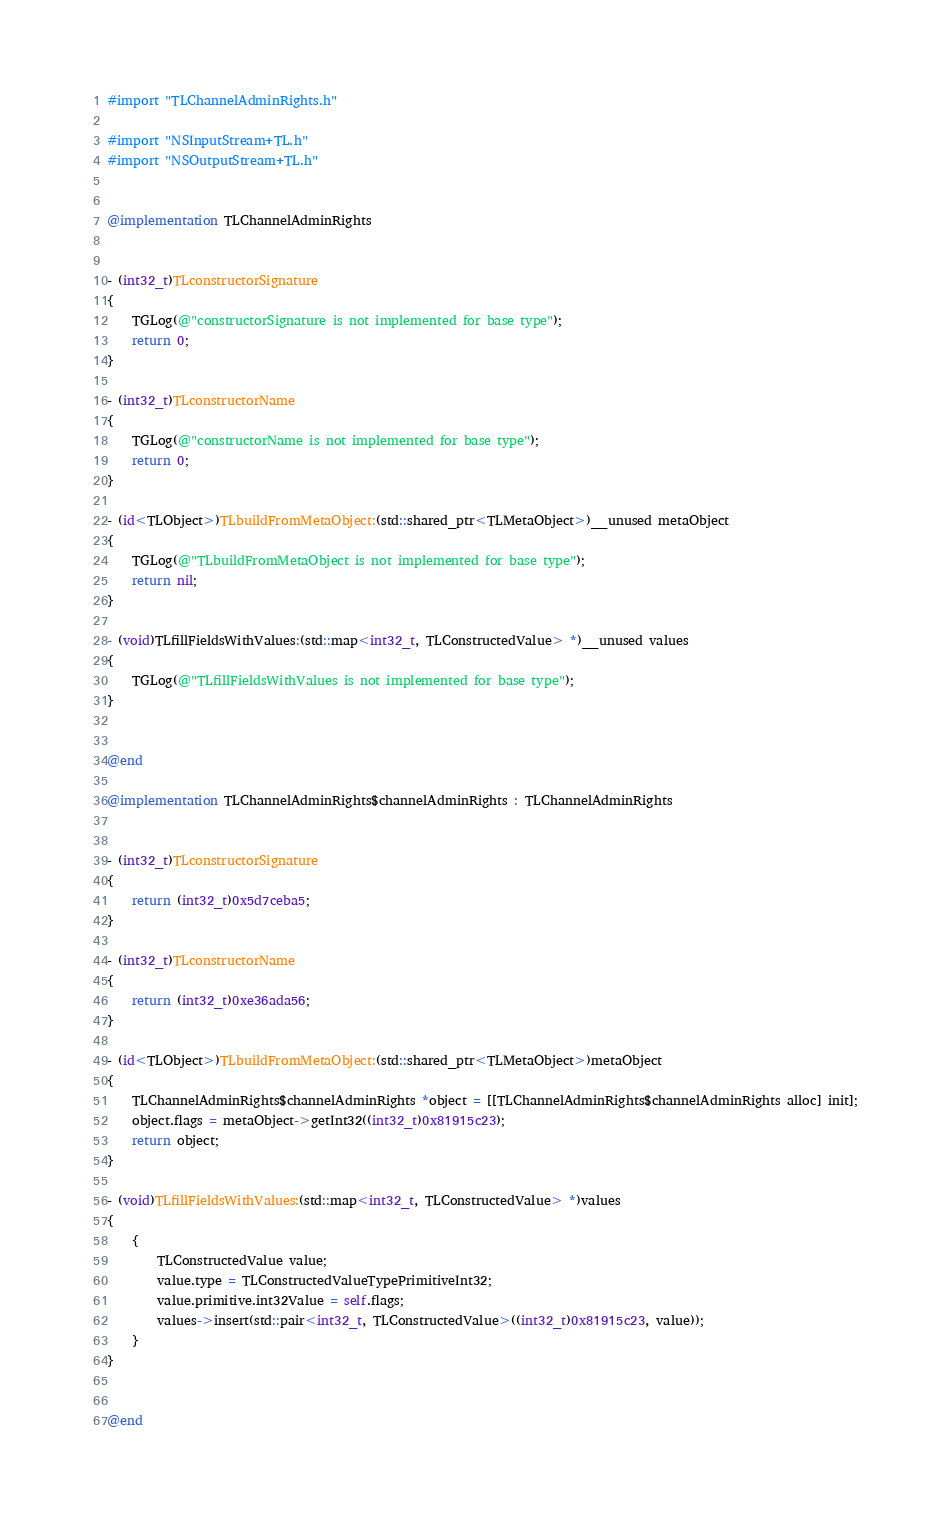Convert code to text. <code><loc_0><loc_0><loc_500><loc_500><_ObjectiveC_>#import "TLChannelAdminRights.h"

#import "NSInputStream+TL.h"
#import "NSOutputStream+TL.h"


@implementation TLChannelAdminRights


- (int32_t)TLconstructorSignature
{
    TGLog(@"constructorSignature is not implemented for base type");
    return 0;
}

- (int32_t)TLconstructorName
{
    TGLog(@"constructorName is not implemented for base type");
    return 0;
}

- (id<TLObject>)TLbuildFromMetaObject:(std::shared_ptr<TLMetaObject>)__unused metaObject
{
    TGLog(@"TLbuildFromMetaObject is not implemented for base type");
    return nil;
}

- (void)TLfillFieldsWithValues:(std::map<int32_t, TLConstructedValue> *)__unused values
{
    TGLog(@"TLfillFieldsWithValues is not implemented for base type");
}


@end

@implementation TLChannelAdminRights$channelAdminRights : TLChannelAdminRights


- (int32_t)TLconstructorSignature
{
    return (int32_t)0x5d7ceba5;
}

- (int32_t)TLconstructorName
{
    return (int32_t)0xe36ada56;
}

- (id<TLObject>)TLbuildFromMetaObject:(std::shared_ptr<TLMetaObject>)metaObject
{
    TLChannelAdminRights$channelAdminRights *object = [[TLChannelAdminRights$channelAdminRights alloc] init];
    object.flags = metaObject->getInt32((int32_t)0x81915c23);
    return object;
}

- (void)TLfillFieldsWithValues:(std::map<int32_t, TLConstructedValue> *)values
{
    {
        TLConstructedValue value;
        value.type = TLConstructedValueTypePrimitiveInt32;
        value.primitive.int32Value = self.flags;
        values->insert(std::pair<int32_t, TLConstructedValue>((int32_t)0x81915c23, value));
    }
}


@end

</code> 